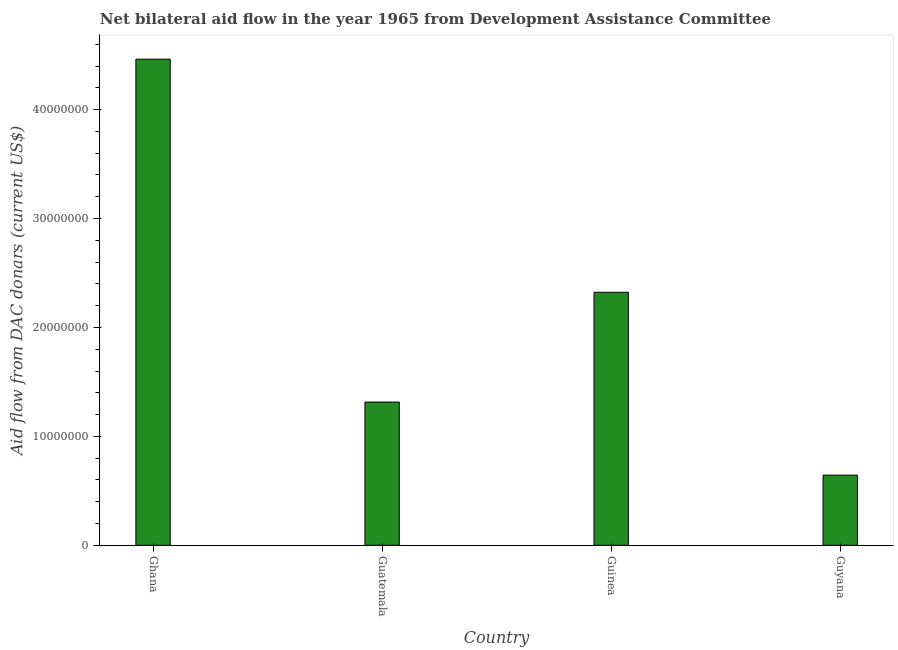What is the title of the graph?
Offer a terse response. Net bilateral aid flow in the year 1965 from Development Assistance Committee. What is the label or title of the X-axis?
Offer a very short reply. Country. What is the label or title of the Y-axis?
Offer a very short reply. Aid flow from DAC donars (current US$). What is the net bilateral aid flows from dac donors in Guatemala?
Provide a short and direct response. 1.32e+07. Across all countries, what is the maximum net bilateral aid flows from dac donors?
Your answer should be compact. 4.46e+07. Across all countries, what is the minimum net bilateral aid flows from dac donors?
Keep it short and to the point. 6.44e+06. In which country was the net bilateral aid flows from dac donors minimum?
Your answer should be very brief. Guyana. What is the sum of the net bilateral aid flows from dac donors?
Provide a short and direct response. 8.74e+07. What is the difference between the net bilateral aid flows from dac donors in Guinea and Guyana?
Provide a short and direct response. 1.68e+07. What is the average net bilateral aid flows from dac donors per country?
Provide a short and direct response. 2.19e+07. What is the median net bilateral aid flows from dac donors?
Make the answer very short. 1.82e+07. What is the ratio of the net bilateral aid flows from dac donors in Ghana to that in Guatemala?
Your answer should be very brief. 3.39. Is the net bilateral aid flows from dac donors in Ghana less than that in Guatemala?
Your answer should be very brief. No. Is the difference between the net bilateral aid flows from dac donors in Guatemala and Guinea greater than the difference between any two countries?
Provide a short and direct response. No. What is the difference between the highest and the second highest net bilateral aid flows from dac donors?
Make the answer very short. 2.14e+07. What is the difference between the highest and the lowest net bilateral aid flows from dac donors?
Offer a very short reply. 3.82e+07. In how many countries, is the net bilateral aid flows from dac donors greater than the average net bilateral aid flows from dac donors taken over all countries?
Make the answer very short. 2. How many countries are there in the graph?
Your answer should be very brief. 4. What is the difference between two consecutive major ticks on the Y-axis?
Your answer should be very brief. 1.00e+07. What is the Aid flow from DAC donars (current US$) of Ghana?
Offer a very short reply. 4.46e+07. What is the Aid flow from DAC donars (current US$) in Guatemala?
Your answer should be very brief. 1.32e+07. What is the Aid flow from DAC donars (current US$) in Guinea?
Keep it short and to the point. 2.32e+07. What is the Aid flow from DAC donars (current US$) in Guyana?
Give a very brief answer. 6.44e+06. What is the difference between the Aid flow from DAC donars (current US$) in Ghana and Guatemala?
Your answer should be compact. 3.15e+07. What is the difference between the Aid flow from DAC donars (current US$) in Ghana and Guinea?
Make the answer very short. 2.14e+07. What is the difference between the Aid flow from DAC donars (current US$) in Ghana and Guyana?
Offer a terse response. 3.82e+07. What is the difference between the Aid flow from DAC donars (current US$) in Guatemala and Guinea?
Your answer should be compact. -1.01e+07. What is the difference between the Aid flow from DAC donars (current US$) in Guatemala and Guyana?
Keep it short and to the point. 6.71e+06. What is the difference between the Aid flow from DAC donars (current US$) in Guinea and Guyana?
Your response must be concise. 1.68e+07. What is the ratio of the Aid flow from DAC donars (current US$) in Ghana to that in Guatemala?
Your answer should be compact. 3.39. What is the ratio of the Aid flow from DAC donars (current US$) in Ghana to that in Guinea?
Provide a short and direct response. 1.92. What is the ratio of the Aid flow from DAC donars (current US$) in Ghana to that in Guyana?
Make the answer very short. 6.93. What is the ratio of the Aid flow from DAC donars (current US$) in Guatemala to that in Guinea?
Provide a succinct answer. 0.57. What is the ratio of the Aid flow from DAC donars (current US$) in Guatemala to that in Guyana?
Keep it short and to the point. 2.04. What is the ratio of the Aid flow from DAC donars (current US$) in Guinea to that in Guyana?
Offer a very short reply. 3.61. 